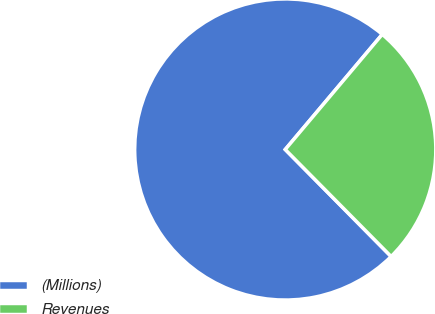Convert chart to OTSL. <chart><loc_0><loc_0><loc_500><loc_500><pie_chart><fcel>(Millions)<fcel>Revenues<nl><fcel>73.56%<fcel>26.44%<nl></chart> 